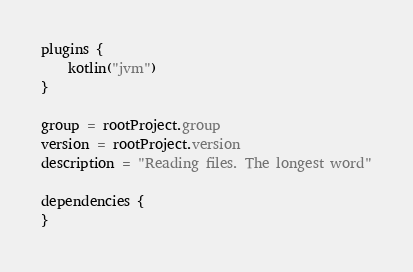<code> <loc_0><loc_0><loc_500><loc_500><_Kotlin_>plugins {
    kotlin("jvm")
}

group = rootProject.group
version = rootProject.version
description = "Reading files. The longest word"

dependencies {
}
</code> 